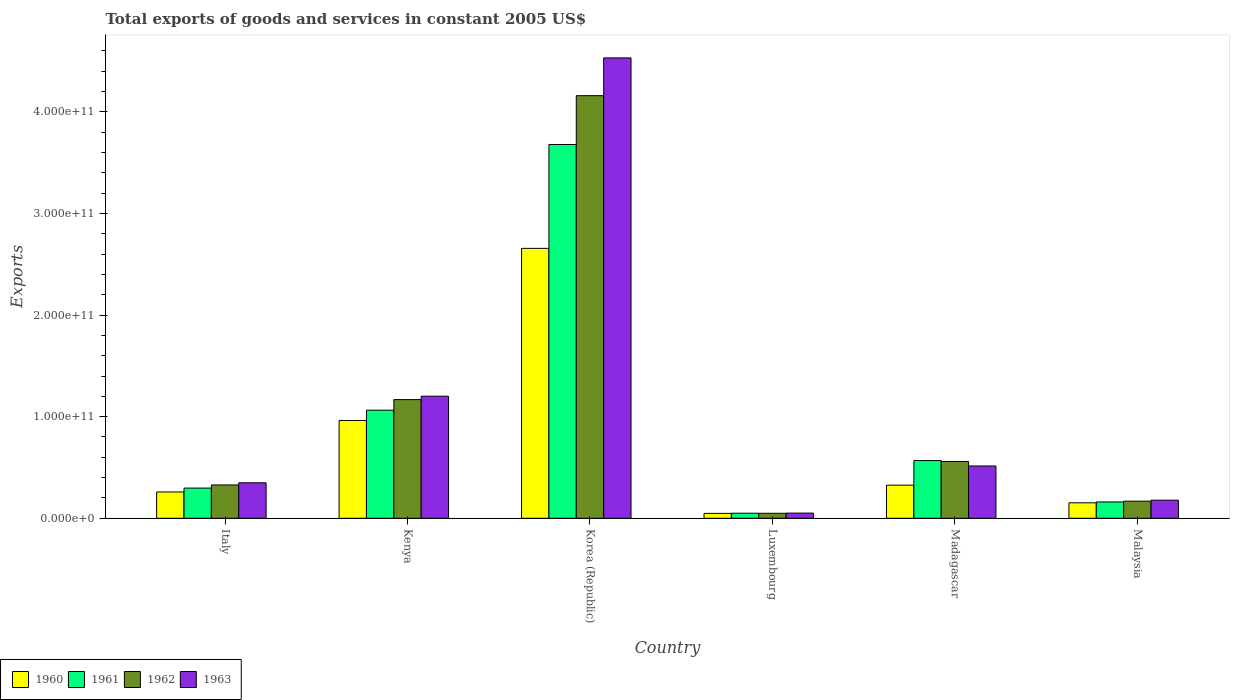Are the number of bars per tick equal to the number of legend labels?
Your answer should be very brief. Yes. Are the number of bars on each tick of the X-axis equal?
Keep it short and to the point. Yes. What is the label of the 2nd group of bars from the left?
Ensure brevity in your answer.  Kenya. In how many cases, is the number of bars for a given country not equal to the number of legend labels?
Your response must be concise. 0. What is the total exports of goods and services in 1963 in Korea (Republic)?
Your response must be concise. 4.53e+11. Across all countries, what is the maximum total exports of goods and services in 1960?
Give a very brief answer. 2.66e+11. Across all countries, what is the minimum total exports of goods and services in 1960?
Keep it short and to the point. 4.81e+09. In which country was the total exports of goods and services in 1961 maximum?
Your answer should be very brief. Korea (Republic). In which country was the total exports of goods and services in 1963 minimum?
Your answer should be compact. Luxembourg. What is the total total exports of goods and services in 1961 in the graph?
Provide a short and direct response. 5.82e+11. What is the difference between the total exports of goods and services in 1963 in Korea (Republic) and that in Luxembourg?
Your answer should be very brief. 4.48e+11. What is the difference between the total exports of goods and services in 1962 in Madagascar and the total exports of goods and services in 1963 in Italy?
Provide a succinct answer. 2.10e+1. What is the average total exports of goods and services in 1960 per country?
Make the answer very short. 7.34e+1. What is the difference between the total exports of goods and services of/in 1963 and total exports of goods and services of/in 1960 in Korea (Republic)?
Your answer should be compact. 1.87e+11. What is the ratio of the total exports of goods and services in 1961 in Kenya to that in Luxembourg?
Give a very brief answer. 21.38. Is the difference between the total exports of goods and services in 1963 in Italy and Luxembourg greater than the difference between the total exports of goods and services in 1960 in Italy and Luxembourg?
Provide a succinct answer. Yes. What is the difference between the highest and the second highest total exports of goods and services in 1963?
Offer a terse response. -3.33e+11. What is the difference between the highest and the lowest total exports of goods and services in 1961?
Your answer should be very brief. 3.63e+11. In how many countries, is the total exports of goods and services in 1960 greater than the average total exports of goods and services in 1960 taken over all countries?
Provide a short and direct response. 2. What does the 1st bar from the right in Madagascar represents?
Your answer should be very brief. 1963. Is it the case that in every country, the sum of the total exports of goods and services in 1963 and total exports of goods and services in 1960 is greater than the total exports of goods and services in 1962?
Give a very brief answer. Yes. How many bars are there?
Offer a terse response. 24. How many countries are there in the graph?
Ensure brevity in your answer.  6. What is the difference between two consecutive major ticks on the Y-axis?
Offer a very short reply. 1.00e+11. Where does the legend appear in the graph?
Keep it short and to the point. Bottom left. How many legend labels are there?
Ensure brevity in your answer.  4. What is the title of the graph?
Offer a very short reply. Total exports of goods and services in constant 2005 US$. What is the label or title of the Y-axis?
Give a very brief answer. Exports. What is the Exports of 1960 in Italy?
Your response must be concise. 2.59e+1. What is the Exports in 1961 in Italy?
Keep it short and to the point. 2.97e+1. What is the Exports of 1962 in Italy?
Provide a short and direct response. 3.28e+1. What is the Exports of 1963 in Italy?
Provide a succinct answer. 3.49e+1. What is the Exports of 1960 in Kenya?
Keep it short and to the point. 9.62e+1. What is the Exports of 1961 in Kenya?
Offer a very short reply. 1.06e+11. What is the Exports of 1962 in Kenya?
Your answer should be compact. 1.17e+11. What is the Exports in 1963 in Kenya?
Offer a terse response. 1.20e+11. What is the Exports in 1960 in Korea (Republic)?
Your response must be concise. 2.66e+11. What is the Exports in 1961 in Korea (Republic)?
Ensure brevity in your answer.  3.68e+11. What is the Exports in 1962 in Korea (Republic)?
Provide a succinct answer. 4.16e+11. What is the Exports of 1963 in Korea (Republic)?
Your answer should be compact. 4.53e+11. What is the Exports in 1960 in Luxembourg?
Make the answer very short. 4.81e+09. What is the Exports in 1961 in Luxembourg?
Make the answer very short. 4.98e+09. What is the Exports in 1962 in Luxembourg?
Your answer should be very brief. 4.90e+09. What is the Exports in 1963 in Luxembourg?
Give a very brief answer. 5.08e+09. What is the Exports in 1960 in Madagascar?
Provide a short and direct response. 3.26e+1. What is the Exports in 1961 in Madagascar?
Offer a very short reply. 5.68e+1. What is the Exports of 1962 in Madagascar?
Your answer should be compact. 5.59e+1. What is the Exports of 1963 in Madagascar?
Make the answer very short. 5.15e+1. What is the Exports of 1960 in Malaysia?
Give a very brief answer. 1.52e+1. What is the Exports in 1961 in Malaysia?
Your response must be concise. 1.61e+1. What is the Exports of 1962 in Malaysia?
Offer a terse response. 1.68e+1. What is the Exports in 1963 in Malaysia?
Offer a very short reply. 1.78e+1. Across all countries, what is the maximum Exports of 1960?
Your answer should be very brief. 2.66e+11. Across all countries, what is the maximum Exports in 1961?
Your answer should be compact. 3.68e+11. Across all countries, what is the maximum Exports in 1962?
Your response must be concise. 4.16e+11. Across all countries, what is the maximum Exports of 1963?
Ensure brevity in your answer.  4.53e+11. Across all countries, what is the minimum Exports of 1960?
Keep it short and to the point. 4.81e+09. Across all countries, what is the minimum Exports in 1961?
Your response must be concise. 4.98e+09. Across all countries, what is the minimum Exports in 1962?
Your answer should be compact. 4.90e+09. Across all countries, what is the minimum Exports of 1963?
Make the answer very short. 5.08e+09. What is the total Exports of 1960 in the graph?
Ensure brevity in your answer.  4.40e+11. What is the total Exports of 1961 in the graph?
Provide a succinct answer. 5.82e+11. What is the total Exports in 1962 in the graph?
Make the answer very short. 6.43e+11. What is the total Exports of 1963 in the graph?
Your answer should be very brief. 6.82e+11. What is the difference between the Exports in 1960 in Italy and that in Kenya?
Make the answer very short. -7.04e+1. What is the difference between the Exports of 1961 in Italy and that in Kenya?
Provide a short and direct response. -7.67e+1. What is the difference between the Exports in 1962 in Italy and that in Kenya?
Your answer should be very brief. -8.40e+1. What is the difference between the Exports in 1963 in Italy and that in Kenya?
Ensure brevity in your answer.  -8.53e+1. What is the difference between the Exports in 1960 in Italy and that in Korea (Republic)?
Provide a succinct answer. -2.40e+11. What is the difference between the Exports in 1961 in Italy and that in Korea (Republic)?
Ensure brevity in your answer.  -3.38e+11. What is the difference between the Exports in 1962 in Italy and that in Korea (Republic)?
Offer a terse response. -3.83e+11. What is the difference between the Exports in 1963 in Italy and that in Korea (Republic)?
Your response must be concise. -4.18e+11. What is the difference between the Exports in 1960 in Italy and that in Luxembourg?
Give a very brief answer. 2.11e+1. What is the difference between the Exports in 1961 in Italy and that in Luxembourg?
Make the answer very short. 2.47e+1. What is the difference between the Exports in 1962 in Italy and that in Luxembourg?
Provide a short and direct response. 2.79e+1. What is the difference between the Exports of 1963 in Italy and that in Luxembourg?
Your answer should be very brief. 2.98e+1. What is the difference between the Exports of 1960 in Italy and that in Madagascar?
Offer a very short reply. -6.70e+09. What is the difference between the Exports of 1961 in Italy and that in Madagascar?
Your response must be concise. -2.71e+1. What is the difference between the Exports in 1962 in Italy and that in Madagascar?
Ensure brevity in your answer.  -2.31e+1. What is the difference between the Exports in 1963 in Italy and that in Madagascar?
Make the answer very short. -1.66e+1. What is the difference between the Exports in 1960 in Italy and that in Malaysia?
Give a very brief answer. 1.07e+1. What is the difference between the Exports of 1961 in Italy and that in Malaysia?
Your answer should be compact. 1.36e+1. What is the difference between the Exports in 1962 in Italy and that in Malaysia?
Give a very brief answer. 1.59e+1. What is the difference between the Exports of 1963 in Italy and that in Malaysia?
Your answer should be compact. 1.71e+1. What is the difference between the Exports in 1960 in Kenya and that in Korea (Republic)?
Offer a terse response. -1.69e+11. What is the difference between the Exports of 1961 in Kenya and that in Korea (Republic)?
Make the answer very short. -2.61e+11. What is the difference between the Exports of 1962 in Kenya and that in Korea (Republic)?
Provide a succinct answer. -2.99e+11. What is the difference between the Exports of 1963 in Kenya and that in Korea (Republic)?
Give a very brief answer. -3.33e+11. What is the difference between the Exports of 1960 in Kenya and that in Luxembourg?
Provide a succinct answer. 9.14e+1. What is the difference between the Exports in 1961 in Kenya and that in Luxembourg?
Make the answer very short. 1.01e+11. What is the difference between the Exports of 1962 in Kenya and that in Luxembourg?
Provide a succinct answer. 1.12e+11. What is the difference between the Exports of 1963 in Kenya and that in Luxembourg?
Keep it short and to the point. 1.15e+11. What is the difference between the Exports of 1960 in Kenya and that in Madagascar?
Offer a very short reply. 6.37e+1. What is the difference between the Exports in 1961 in Kenya and that in Madagascar?
Give a very brief answer. 4.96e+1. What is the difference between the Exports in 1962 in Kenya and that in Madagascar?
Provide a short and direct response. 6.09e+1. What is the difference between the Exports in 1963 in Kenya and that in Madagascar?
Keep it short and to the point. 6.87e+1. What is the difference between the Exports in 1960 in Kenya and that in Malaysia?
Keep it short and to the point. 8.10e+1. What is the difference between the Exports in 1961 in Kenya and that in Malaysia?
Offer a terse response. 9.03e+1. What is the difference between the Exports in 1962 in Kenya and that in Malaysia?
Offer a very short reply. 9.99e+1. What is the difference between the Exports in 1963 in Kenya and that in Malaysia?
Keep it short and to the point. 1.02e+11. What is the difference between the Exports in 1960 in Korea (Republic) and that in Luxembourg?
Your response must be concise. 2.61e+11. What is the difference between the Exports in 1961 in Korea (Republic) and that in Luxembourg?
Offer a terse response. 3.63e+11. What is the difference between the Exports of 1962 in Korea (Republic) and that in Luxembourg?
Provide a succinct answer. 4.11e+11. What is the difference between the Exports in 1963 in Korea (Republic) and that in Luxembourg?
Your answer should be compact. 4.48e+11. What is the difference between the Exports in 1960 in Korea (Republic) and that in Madagascar?
Keep it short and to the point. 2.33e+11. What is the difference between the Exports in 1961 in Korea (Republic) and that in Madagascar?
Provide a succinct answer. 3.11e+11. What is the difference between the Exports of 1962 in Korea (Republic) and that in Madagascar?
Ensure brevity in your answer.  3.60e+11. What is the difference between the Exports of 1963 in Korea (Republic) and that in Madagascar?
Provide a short and direct response. 4.02e+11. What is the difference between the Exports in 1960 in Korea (Republic) and that in Malaysia?
Keep it short and to the point. 2.50e+11. What is the difference between the Exports in 1961 in Korea (Republic) and that in Malaysia?
Make the answer very short. 3.52e+11. What is the difference between the Exports of 1962 in Korea (Republic) and that in Malaysia?
Give a very brief answer. 3.99e+11. What is the difference between the Exports of 1963 in Korea (Republic) and that in Malaysia?
Keep it short and to the point. 4.35e+11. What is the difference between the Exports in 1960 in Luxembourg and that in Madagascar?
Provide a succinct answer. -2.78e+1. What is the difference between the Exports in 1961 in Luxembourg and that in Madagascar?
Ensure brevity in your answer.  -5.18e+1. What is the difference between the Exports of 1962 in Luxembourg and that in Madagascar?
Provide a succinct answer. -5.10e+1. What is the difference between the Exports of 1963 in Luxembourg and that in Madagascar?
Keep it short and to the point. -4.64e+1. What is the difference between the Exports in 1960 in Luxembourg and that in Malaysia?
Offer a very short reply. -1.04e+1. What is the difference between the Exports in 1961 in Luxembourg and that in Malaysia?
Provide a succinct answer. -1.11e+1. What is the difference between the Exports of 1962 in Luxembourg and that in Malaysia?
Provide a succinct answer. -1.19e+1. What is the difference between the Exports of 1963 in Luxembourg and that in Malaysia?
Provide a short and direct response. -1.27e+1. What is the difference between the Exports of 1960 in Madagascar and that in Malaysia?
Offer a very short reply. 1.74e+1. What is the difference between the Exports in 1961 in Madagascar and that in Malaysia?
Your answer should be compact. 4.07e+1. What is the difference between the Exports in 1962 in Madagascar and that in Malaysia?
Your response must be concise. 3.91e+1. What is the difference between the Exports in 1963 in Madagascar and that in Malaysia?
Keep it short and to the point. 3.36e+1. What is the difference between the Exports of 1960 in Italy and the Exports of 1961 in Kenya?
Provide a short and direct response. -8.05e+1. What is the difference between the Exports of 1960 in Italy and the Exports of 1962 in Kenya?
Your answer should be compact. -9.09e+1. What is the difference between the Exports of 1960 in Italy and the Exports of 1963 in Kenya?
Offer a very short reply. -9.43e+1. What is the difference between the Exports of 1961 in Italy and the Exports of 1962 in Kenya?
Your answer should be very brief. -8.71e+1. What is the difference between the Exports in 1961 in Italy and the Exports in 1963 in Kenya?
Give a very brief answer. -9.05e+1. What is the difference between the Exports of 1962 in Italy and the Exports of 1963 in Kenya?
Your answer should be compact. -8.74e+1. What is the difference between the Exports of 1960 in Italy and the Exports of 1961 in Korea (Republic)?
Provide a succinct answer. -3.42e+11. What is the difference between the Exports in 1960 in Italy and the Exports in 1962 in Korea (Republic)?
Give a very brief answer. -3.90e+11. What is the difference between the Exports in 1960 in Italy and the Exports in 1963 in Korea (Republic)?
Give a very brief answer. -4.27e+11. What is the difference between the Exports in 1961 in Italy and the Exports in 1962 in Korea (Republic)?
Your answer should be compact. -3.86e+11. What is the difference between the Exports of 1961 in Italy and the Exports of 1963 in Korea (Republic)?
Keep it short and to the point. -4.23e+11. What is the difference between the Exports of 1962 in Italy and the Exports of 1963 in Korea (Republic)?
Offer a very short reply. -4.20e+11. What is the difference between the Exports in 1960 in Italy and the Exports in 1961 in Luxembourg?
Offer a very short reply. 2.09e+1. What is the difference between the Exports in 1960 in Italy and the Exports in 1962 in Luxembourg?
Your answer should be very brief. 2.10e+1. What is the difference between the Exports in 1960 in Italy and the Exports in 1963 in Luxembourg?
Offer a terse response. 2.08e+1. What is the difference between the Exports in 1961 in Italy and the Exports in 1962 in Luxembourg?
Offer a terse response. 2.48e+1. What is the difference between the Exports in 1961 in Italy and the Exports in 1963 in Luxembourg?
Your answer should be very brief. 2.46e+1. What is the difference between the Exports of 1962 in Italy and the Exports of 1963 in Luxembourg?
Your response must be concise. 2.77e+1. What is the difference between the Exports of 1960 in Italy and the Exports of 1961 in Madagascar?
Your answer should be compact. -3.09e+1. What is the difference between the Exports in 1960 in Italy and the Exports in 1962 in Madagascar?
Give a very brief answer. -3.00e+1. What is the difference between the Exports in 1960 in Italy and the Exports in 1963 in Madagascar?
Provide a succinct answer. -2.56e+1. What is the difference between the Exports of 1961 in Italy and the Exports of 1962 in Madagascar?
Your response must be concise. -2.62e+1. What is the difference between the Exports of 1961 in Italy and the Exports of 1963 in Madagascar?
Provide a short and direct response. -2.18e+1. What is the difference between the Exports in 1962 in Italy and the Exports in 1963 in Madagascar?
Make the answer very short. -1.87e+1. What is the difference between the Exports in 1960 in Italy and the Exports in 1961 in Malaysia?
Provide a short and direct response. 9.82e+09. What is the difference between the Exports of 1960 in Italy and the Exports of 1962 in Malaysia?
Offer a very short reply. 9.05e+09. What is the difference between the Exports in 1960 in Italy and the Exports in 1963 in Malaysia?
Your response must be concise. 8.06e+09. What is the difference between the Exports of 1961 in Italy and the Exports of 1962 in Malaysia?
Your answer should be very brief. 1.29e+1. What is the difference between the Exports of 1961 in Italy and the Exports of 1963 in Malaysia?
Give a very brief answer. 1.19e+1. What is the difference between the Exports of 1962 in Italy and the Exports of 1963 in Malaysia?
Provide a succinct answer. 1.50e+1. What is the difference between the Exports in 1960 in Kenya and the Exports in 1961 in Korea (Republic)?
Provide a succinct answer. -2.72e+11. What is the difference between the Exports in 1960 in Kenya and the Exports in 1962 in Korea (Republic)?
Your answer should be very brief. -3.20e+11. What is the difference between the Exports of 1960 in Kenya and the Exports of 1963 in Korea (Republic)?
Offer a terse response. -3.57e+11. What is the difference between the Exports in 1961 in Kenya and the Exports in 1962 in Korea (Republic)?
Your answer should be very brief. -3.09e+11. What is the difference between the Exports of 1961 in Kenya and the Exports of 1963 in Korea (Republic)?
Your answer should be compact. -3.47e+11. What is the difference between the Exports of 1962 in Kenya and the Exports of 1963 in Korea (Republic)?
Keep it short and to the point. -3.36e+11. What is the difference between the Exports in 1960 in Kenya and the Exports in 1961 in Luxembourg?
Offer a very short reply. 9.13e+1. What is the difference between the Exports of 1960 in Kenya and the Exports of 1962 in Luxembourg?
Offer a very short reply. 9.13e+1. What is the difference between the Exports in 1960 in Kenya and the Exports in 1963 in Luxembourg?
Make the answer very short. 9.12e+1. What is the difference between the Exports in 1961 in Kenya and the Exports in 1962 in Luxembourg?
Provide a short and direct response. 1.01e+11. What is the difference between the Exports of 1961 in Kenya and the Exports of 1963 in Luxembourg?
Your response must be concise. 1.01e+11. What is the difference between the Exports of 1962 in Kenya and the Exports of 1963 in Luxembourg?
Your response must be concise. 1.12e+11. What is the difference between the Exports of 1960 in Kenya and the Exports of 1961 in Madagascar?
Give a very brief answer. 3.94e+1. What is the difference between the Exports in 1960 in Kenya and the Exports in 1962 in Madagascar?
Your answer should be compact. 4.03e+1. What is the difference between the Exports of 1960 in Kenya and the Exports of 1963 in Madagascar?
Provide a succinct answer. 4.48e+1. What is the difference between the Exports in 1961 in Kenya and the Exports in 1962 in Madagascar?
Keep it short and to the point. 5.05e+1. What is the difference between the Exports of 1961 in Kenya and the Exports of 1963 in Madagascar?
Offer a very short reply. 5.49e+1. What is the difference between the Exports in 1962 in Kenya and the Exports in 1963 in Madagascar?
Keep it short and to the point. 6.53e+1. What is the difference between the Exports of 1960 in Kenya and the Exports of 1961 in Malaysia?
Provide a succinct answer. 8.02e+1. What is the difference between the Exports of 1960 in Kenya and the Exports of 1962 in Malaysia?
Your response must be concise. 7.94e+1. What is the difference between the Exports in 1960 in Kenya and the Exports in 1963 in Malaysia?
Your answer should be compact. 7.84e+1. What is the difference between the Exports in 1961 in Kenya and the Exports in 1962 in Malaysia?
Your answer should be very brief. 8.96e+1. What is the difference between the Exports in 1961 in Kenya and the Exports in 1963 in Malaysia?
Keep it short and to the point. 8.86e+1. What is the difference between the Exports of 1962 in Kenya and the Exports of 1963 in Malaysia?
Offer a very short reply. 9.89e+1. What is the difference between the Exports of 1960 in Korea (Republic) and the Exports of 1961 in Luxembourg?
Make the answer very short. 2.61e+11. What is the difference between the Exports of 1960 in Korea (Republic) and the Exports of 1962 in Luxembourg?
Provide a succinct answer. 2.61e+11. What is the difference between the Exports in 1960 in Korea (Republic) and the Exports in 1963 in Luxembourg?
Your answer should be very brief. 2.61e+11. What is the difference between the Exports of 1961 in Korea (Republic) and the Exports of 1962 in Luxembourg?
Your answer should be very brief. 3.63e+11. What is the difference between the Exports in 1961 in Korea (Republic) and the Exports in 1963 in Luxembourg?
Provide a short and direct response. 3.63e+11. What is the difference between the Exports in 1962 in Korea (Republic) and the Exports in 1963 in Luxembourg?
Your answer should be compact. 4.11e+11. What is the difference between the Exports in 1960 in Korea (Republic) and the Exports in 1961 in Madagascar?
Make the answer very short. 2.09e+11. What is the difference between the Exports in 1960 in Korea (Republic) and the Exports in 1962 in Madagascar?
Offer a very short reply. 2.10e+11. What is the difference between the Exports of 1960 in Korea (Republic) and the Exports of 1963 in Madagascar?
Ensure brevity in your answer.  2.14e+11. What is the difference between the Exports of 1961 in Korea (Republic) and the Exports of 1962 in Madagascar?
Make the answer very short. 3.12e+11. What is the difference between the Exports of 1961 in Korea (Republic) and the Exports of 1963 in Madagascar?
Your response must be concise. 3.16e+11. What is the difference between the Exports in 1962 in Korea (Republic) and the Exports in 1963 in Madagascar?
Give a very brief answer. 3.64e+11. What is the difference between the Exports in 1960 in Korea (Republic) and the Exports in 1961 in Malaysia?
Your answer should be very brief. 2.50e+11. What is the difference between the Exports in 1960 in Korea (Republic) and the Exports in 1962 in Malaysia?
Ensure brevity in your answer.  2.49e+11. What is the difference between the Exports in 1960 in Korea (Republic) and the Exports in 1963 in Malaysia?
Ensure brevity in your answer.  2.48e+11. What is the difference between the Exports of 1961 in Korea (Republic) and the Exports of 1962 in Malaysia?
Make the answer very short. 3.51e+11. What is the difference between the Exports of 1961 in Korea (Republic) and the Exports of 1963 in Malaysia?
Ensure brevity in your answer.  3.50e+11. What is the difference between the Exports of 1962 in Korea (Republic) and the Exports of 1963 in Malaysia?
Keep it short and to the point. 3.98e+11. What is the difference between the Exports of 1960 in Luxembourg and the Exports of 1961 in Madagascar?
Make the answer very short. -5.20e+1. What is the difference between the Exports in 1960 in Luxembourg and the Exports in 1962 in Madagascar?
Give a very brief answer. -5.11e+1. What is the difference between the Exports in 1960 in Luxembourg and the Exports in 1963 in Madagascar?
Make the answer very short. -4.67e+1. What is the difference between the Exports of 1961 in Luxembourg and the Exports of 1962 in Madagascar?
Your response must be concise. -5.09e+1. What is the difference between the Exports in 1961 in Luxembourg and the Exports in 1963 in Madagascar?
Offer a very short reply. -4.65e+1. What is the difference between the Exports of 1962 in Luxembourg and the Exports of 1963 in Madagascar?
Offer a terse response. -4.66e+1. What is the difference between the Exports of 1960 in Luxembourg and the Exports of 1961 in Malaysia?
Offer a very short reply. -1.13e+1. What is the difference between the Exports of 1960 in Luxembourg and the Exports of 1962 in Malaysia?
Make the answer very short. -1.20e+1. What is the difference between the Exports of 1960 in Luxembourg and the Exports of 1963 in Malaysia?
Offer a terse response. -1.30e+1. What is the difference between the Exports in 1961 in Luxembourg and the Exports in 1962 in Malaysia?
Provide a succinct answer. -1.19e+1. What is the difference between the Exports of 1961 in Luxembourg and the Exports of 1963 in Malaysia?
Offer a very short reply. -1.28e+1. What is the difference between the Exports of 1962 in Luxembourg and the Exports of 1963 in Malaysia?
Offer a terse response. -1.29e+1. What is the difference between the Exports of 1960 in Madagascar and the Exports of 1961 in Malaysia?
Your answer should be very brief. 1.65e+1. What is the difference between the Exports in 1960 in Madagascar and the Exports in 1962 in Malaysia?
Your answer should be compact. 1.57e+1. What is the difference between the Exports of 1960 in Madagascar and the Exports of 1963 in Malaysia?
Your response must be concise. 1.48e+1. What is the difference between the Exports of 1961 in Madagascar and the Exports of 1962 in Malaysia?
Your response must be concise. 4.00e+1. What is the difference between the Exports of 1961 in Madagascar and the Exports of 1963 in Malaysia?
Your answer should be compact. 3.90e+1. What is the difference between the Exports in 1962 in Madagascar and the Exports in 1963 in Malaysia?
Offer a terse response. 3.81e+1. What is the average Exports of 1960 per country?
Provide a short and direct response. 7.34e+1. What is the average Exports of 1961 per country?
Make the answer very short. 9.70e+1. What is the average Exports of 1962 per country?
Your answer should be compact. 1.07e+11. What is the average Exports of 1963 per country?
Offer a terse response. 1.14e+11. What is the difference between the Exports in 1960 and Exports in 1961 in Italy?
Keep it short and to the point. -3.82e+09. What is the difference between the Exports in 1960 and Exports in 1962 in Italy?
Provide a succinct answer. -6.90e+09. What is the difference between the Exports in 1960 and Exports in 1963 in Italy?
Offer a very short reply. -9.02e+09. What is the difference between the Exports of 1961 and Exports of 1962 in Italy?
Keep it short and to the point. -3.08e+09. What is the difference between the Exports in 1961 and Exports in 1963 in Italy?
Your answer should be compact. -5.20e+09. What is the difference between the Exports in 1962 and Exports in 1963 in Italy?
Provide a short and direct response. -2.13e+09. What is the difference between the Exports in 1960 and Exports in 1961 in Kenya?
Provide a succinct answer. -1.01e+1. What is the difference between the Exports of 1960 and Exports of 1962 in Kenya?
Your response must be concise. -2.05e+1. What is the difference between the Exports in 1960 and Exports in 1963 in Kenya?
Offer a very short reply. -2.39e+1. What is the difference between the Exports of 1961 and Exports of 1962 in Kenya?
Your response must be concise. -1.04e+1. What is the difference between the Exports in 1961 and Exports in 1963 in Kenya?
Your answer should be compact. -1.38e+1. What is the difference between the Exports of 1962 and Exports of 1963 in Kenya?
Make the answer very short. -3.39e+09. What is the difference between the Exports in 1960 and Exports in 1961 in Korea (Republic)?
Your answer should be compact. -1.02e+11. What is the difference between the Exports in 1960 and Exports in 1962 in Korea (Republic)?
Offer a terse response. -1.50e+11. What is the difference between the Exports in 1960 and Exports in 1963 in Korea (Republic)?
Your answer should be compact. -1.87e+11. What is the difference between the Exports in 1961 and Exports in 1962 in Korea (Republic)?
Provide a succinct answer. -4.81e+1. What is the difference between the Exports of 1961 and Exports of 1963 in Korea (Republic)?
Offer a terse response. -8.52e+1. What is the difference between the Exports in 1962 and Exports in 1963 in Korea (Republic)?
Ensure brevity in your answer.  -3.72e+1. What is the difference between the Exports of 1960 and Exports of 1961 in Luxembourg?
Keep it short and to the point. -1.68e+08. What is the difference between the Exports of 1960 and Exports of 1962 in Luxembourg?
Your response must be concise. -8.82e+07. What is the difference between the Exports in 1960 and Exports in 1963 in Luxembourg?
Offer a terse response. -2.73e+08. What is the difference between the Exports in 1961 and Exports in 1962 in Luxembourg?
Your answer should be compact. 7.94e+07. What is the difference between the Exports of 1961 and Exports of 1963 in Luxembourg?
Provide a short and direct response. -1.05e+08. What is the difference between the Exports of 1962 and Exports of 1963 in Luxembourg?
Make the answer very short. -1.85e+08. What is the difference between the Exports of 1960 and Exports of 1961 in Madagascar?
Provide a short and direct response. -2.42e+1. What is the difference between the Exports of 1960 and Exports of 1962 in Madagascar?
Give a very brief answer. -2.33e+1. What is the difference between the Exports of 1960 and Exports of 1963 in Madagascar?
Offer a very short reply. -1.89e+1. What is the difference between the Exports in 1961 and Exports in 1962 in Madagascar?
Your answer should be very brief. 8.87e+08. What is the difference between the Exports in 1961 and Exports in 1963 in Madagascar?
Offer a terse response. 5.32e+09. What is the difference between the Exports of 1962 and Exports of 1963 in Madagascar?
Your response must be concise. 4.44e+09. What is the difference between the Exports of 1960 and Exports of 1961 in Malaysia?
Provide a succinct answer. -8.42e+08. What is the difference between the Exports in 1960 and Exports in 1962 in Malaysia?
Keep it short and to the point. -1.61e+09. What is the difference between the Exports in 1960 and Exports in 1963 in Malaysia?
Give a very brief answer. -2.60e+09. What is the difference between the Exports in 1961 and Exports in 1962 in Malaysia?
Your response must be concise. -7.72e+08. What is the difference between the Exports of 1961 and Exports of 1963 in Malaysia?
Your answer should be very brief. -1.76e+09. What is the difference between the Exports of 1962 and Exports of 1963 in Malaysia?
Make the answer very short. -9.85e+08. What is the ratio of the Exports of 1960 in Italy to that in Kenya?
Keep it short and to the point. 0.27. What is the ratio of the Exports in 1961 in Italy to that in Kenya?
Offer a terse response. 0.28. What is the ratio of the Exports of 1962 in Italy to that in Kenya?
Your response must be concise. 0.28. What is the ratio of the Exports in 1963 in Italy to that in Kenya?
Give a very brief answer. 0.29. What is the ratio of the Exports of 1960 in Italy to that in Korea (Republic)?
Your response must be concise. 0.1. What is the ratio of the Exports in 1961 in Italy to that in Korea (Republic)?
Your response must be concise. 0.08. What is the ratio of the Exports in 1962 in Italy to that in Korea (Republic)?
Provide a short and direct response. 0.08. What is the ratio of the Exports of 1963 in Italy to that in Korea (Republic)?
Provide a short and direct response. 0.08. What is the ratio of the Exports of 1960 in Italy to that in Luxembourg?
Your response must be concise. 5.38. What is the ratio of the Exports in 1961 in Italy to that in Luxembourg?
Your answer should be very brief. 5.97. What is the ratio of the Exports of 1962 in Italy to that in Luxembourg?
Give a very brief answer. 6.69. What is the ratio of the Exports in 1963 in Italy to that in Luxembourg?
Ensure brevity in your answer.  6.87. What is the ratio of the Exports in 1960 in Italy to that in Madagascar?
Provide a succinct answer. 0.79. What is the ratio of the Exports of 1961 in Italy to that in Madagascar?
Offer a very short reply. 0.52. What is the ratio of the Exports of 1962 in Italy to that in Madagascar?
Provide a succinct answer. 0.59. What is the ratio of the Exports of 1963 in Italy to that in Madagascar?
Your response must be concise. 0.68. What is the ratio of the Exports in 1960 in Italy to that in Malaysia?
Your answer should be very brief. 1.7. What is the ratio of the Exports in 1961 in Italy to that in Malaysia?
Keep it short and to the point. 1.85. What is the ratio of the Exports of 1962 in Italy to that in Malaysia?
Provide a short and direct response. 1.95. What is the ratio of the Exports in 1963 in Italy to that in Malaysia?
Offer a terse response. 1.96. What is the ratio of the Exports of 1960 in Kenya to that in Korea (Republic)?
Your answer should be very brief. 0.36. What is the ratio of the Exports of 1961 in Kenya to that in Korea (Republic)?
Your answer should be very brief. 0.29. What is the ratio of the Exports in 1962 in Kenya to that in Korea (Republic)?
Provide a short and direct response. 0.28. What is the ratio of the Exports in 1963 in Kenya to that in Korea (Republic)?
Make the answer very short. 0.27. What is the ratio of the Exports in 1960 in Kenya to that in Luxembourg?
Provide a succinct answer. 20.01. What is the ratio of the Exports of 1961 in Kenya to that in Luxembourg?
Your answer should be compact. 21.38. What is the ratio of the Exports of 1962 in Kenya to that in Luxembourg?
Your answer should be compact. 23.84. What is the ratio of the Exports in 1963 in Kenya to that in Luxembourg?
Provide a succinct answer. 23.64. What is the ratio of the Exports of 1960 in Kenya to that in Madagascar?
Provide a short and direct response. 2.95. What is the ratio of the Exports in 1961 in Kenya to that in Madagascar?
Provide a short and direct response. 1.87. What is the ratio of the Exports in 1962 in Kenya to that in Madagascar?
Provide a succinct answer. 2.09. What is the ratio of the Exports of 1963 in Kenya to that in Madagascar?
Provide a short and direct response. 2.33. What is the ratio of the Exports of 1960 in Kenya to that in Malaysia?
Keep it short and to the point. 6.32. What is the ratio of the Exports in 1961 in Kenya to that in Malaysia?
Provide a short and direct response. 6.62. What is the ratio of the Exports in 1962 in Kenya to that in Malaysia?
Make the answer very short. 6.94. What is the ratio of the Exports in 1963 in Kenya to that in Malaysia?
Offer a very short reply. 6.74. What is the ratio of the Exports of 1960 in Korea (Republic) to that in Luxembourg?
Provide a short and direct response. 55.23. What is the ratio of the Exports of 1961 in Korea (Republic) to that in Luxembourg?
Provide a succinct answer. 73.91. What is the ratio of the Exports in 1962 in Korea (Republic) to that in Luxembourg?
Give a very brief answer. 84.92. What is the ratio of the Exports of 1963 in Korea (Republic) to that in Luxembourg?
Your answer should be very brief. 89.15. What is the ratio of the Exports in 1960 in Korea (Republic) to that in Madagascar?
Ensure brevity in your answer.  8.15. What is the ratio of the Exports of 1961 in Korea (Republic) to that in Madagascar?
Your response must be concise. 6.48. What is the ratio of the Exports of 1962 in Korea (Republic) to that in Madagascar?
Give a very brief answer. 7.44. What is the ratio of the Exports in 1963 in Korea (Republic) to that in Madagascar?
Make the answer very short. 8.8. What is the ratio of the Exports of 1960 in Korea (Republic) to that in Malaysia?
Keep it short and to the point. 17.45. What is the ratio of the Exports of 1961 in Korea (Republic) to that in Malaysia?
Offer a very short reply. 22.9. What is the ratio of the Exports of 1962 in Korea (Republic) to that in Malaysia?
Provide a short and direct response. 24.7. What is the ratio of the Exports of 1963 in Korea (Republic) to that in Malaysia?
Make the answer very short. 25.42. What is the ratio of the Exports of 1960 in Luxembourg to that in Madagascar?
Offer a very short reply. 0.15. What is the ratio of the Exports in 1961 in Luxembourg to that in Madagascar?
Your response must be concise. 0.09. What is the ratio of the Exports of 1962 in Luxembourg to that in Madagascar?
Your answer should be very brief. 0.09. What is the ratio of the Exports of 1963 in Luxembourg to that in Madagascar?
Ensure brevity in your answer.  0.1. What is the ratio of the Exports in 1960 in Luxembourg to that in Malaysia?
Your answer should be compact. 0.32. What is the ratio of the Exports of 1961 in Luxembourg to that in Malaysia?
Keep it short and to the point. 0.31. What is the ratio of the Exports of 1962 in Luxembourg to that in Malaysia?
Provide a short and direct response. 0.29. What is the ratio of the Exports of 1963 in Luxembourg to that in Malaysia?
Give a very brief answer. 0.29. What is the ratio of the Exports in 1960 in Madagascar to that in Malaysia?
Your answer should be compact. 2.14. What is the ratio of the Exports of 1961 in Madagascar to that in Malaysia?
Offer a very short reply. 3.54. What is the ratio of the Exports in 1962 in Madagascar to that in Malaysia?
Make the answer very short. 3.32. What is the ratio of the Exports of 1963 in Madagascar to that in Malaysia?
Give a very brief answer. 2.89. What is the difference between the highest and the second highest Exports in 1960?
Give a very brief answer. 1.69e+11. What is the difference between the highest and the second highest Exports of 1961?
Offer a very short reply. 2.61e+11. What is the difference between the highest and the second highest Exports in 1962?
Give a very brief answer. 2.99e+11. What is the difference between the highest and the second highest Exports of 1963?
Offer a very short reply. 3.33e+11. What is the difference between the highest and the lowest Exports of 1960?
Provide a short and direct response. 2.61e+11. What is the difference between the highest and the lowest Exports in 1961?
Give a very brief answer. 3.63e+11. What is the difference between the highest and the lowest Exports of 1962?
Make the answer very short. 4.11e+11. What is the difference between the highest and the lowest Exports of 1963?
Provide a succinct answer. 4.48e+11. 